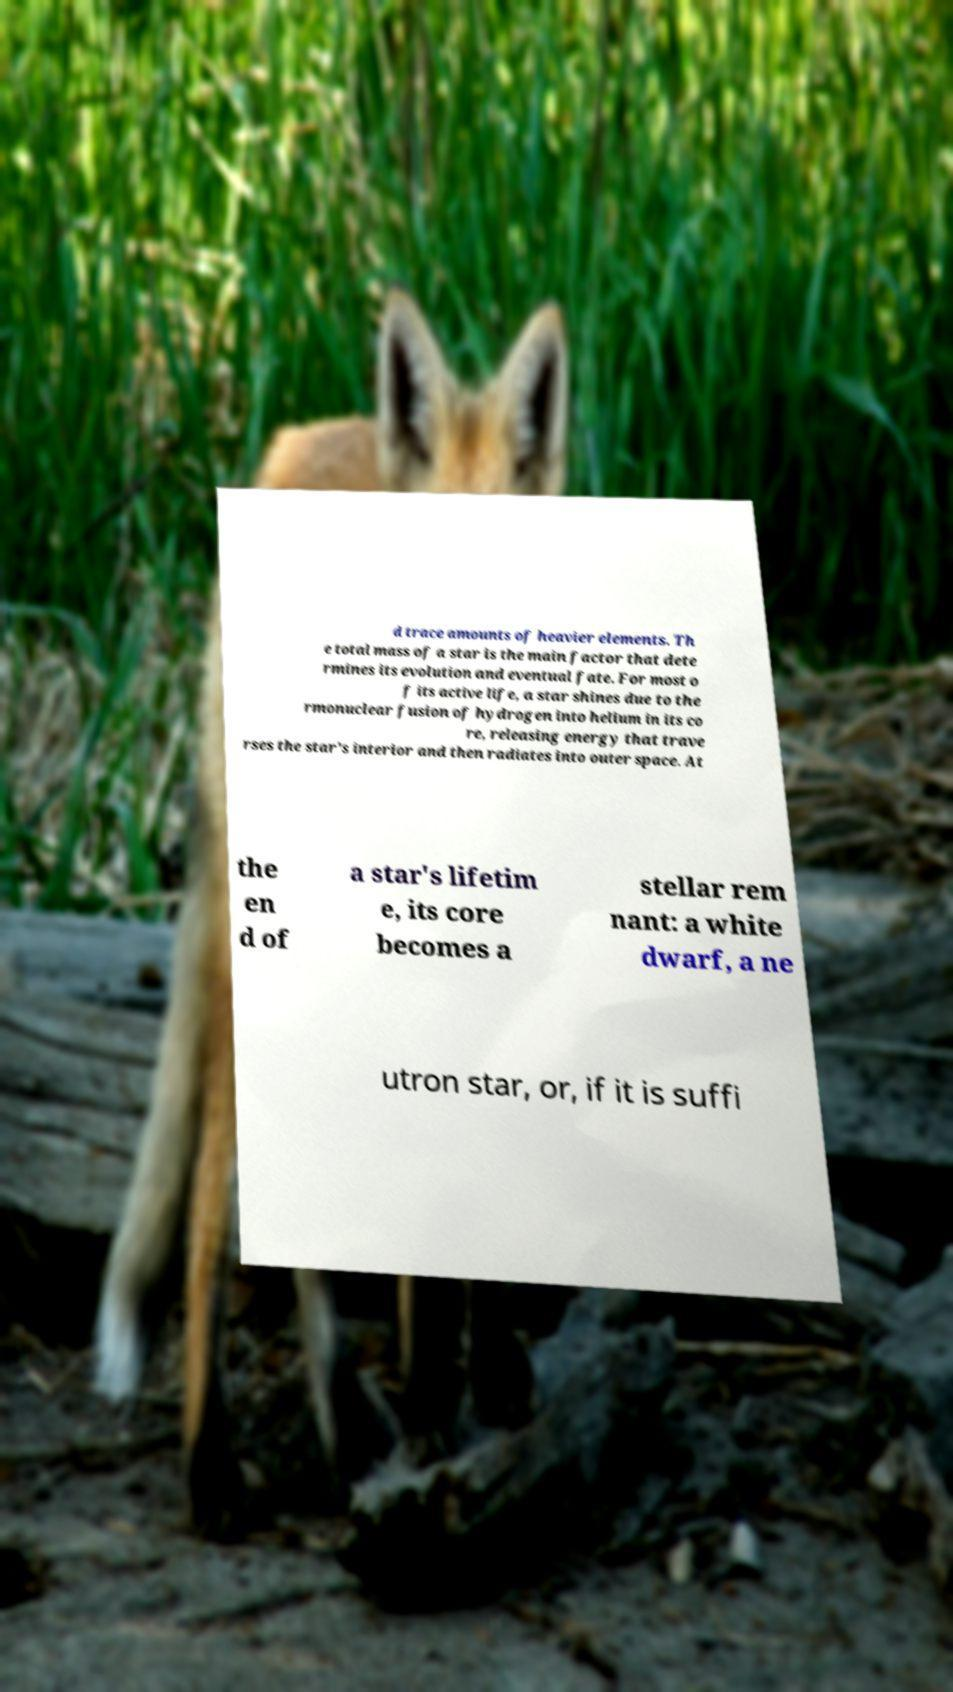Can you read and provide the text displayed in the image?This photo seems to have some interesting text. Can you extract and type it out for me? d trace amounts of heavier elements. Th e total mass of a star is the main factor that dete rmines its evolution and eventual fate. For most o f its active life, a star shines due to the rmonuclear fusion of hydrogen into helium in its co re, releasing energy that trave rses the star's interior and then radiates into outer space. At the en d of a star's lifetim e, its core becomes a stellar rem nant: a white dwarf, a ne utron star, or, if it is suffi 